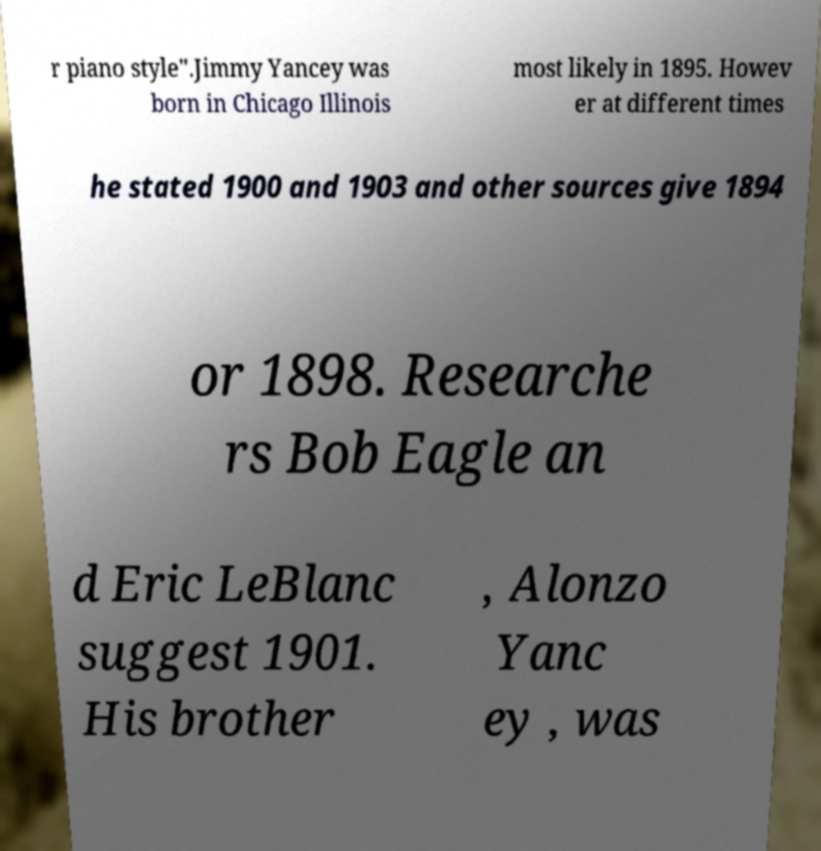Can you read and provide the text displayed in the image?This photo seems to have some interesting text. Can you extract and type it out for me? r piano style".Jimmy Yancey was born in Chicago Illinois most likely in 1895. Howev er at different times he stated 1900 and 1903 and other sources give 1894 or 1898. Researche rs Bob Eagle an d Eric LeBlanc suggest 1901. His brother , Alonzo Yanc ey , was 